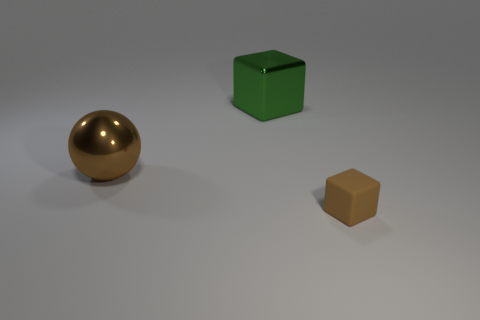Add 3 red matte blocks. How many objects exist? 6 Subtract all rubber cylinders. Subtract all brown things. How many objects are left? 1 Add 2 green metal blocks. How many green metal blocks are left? 3 Add 2 gray shiny objects. How many gray shiny objects exist? 2 Subtract 1 green cubes. How many objects are left? 2 Subtract all cubes. How many objects are left? 1 